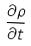<formula> <loc_0><loc_0><loc_500><loc_500>\frac { \partial \rho } { \partial t }</formula> 